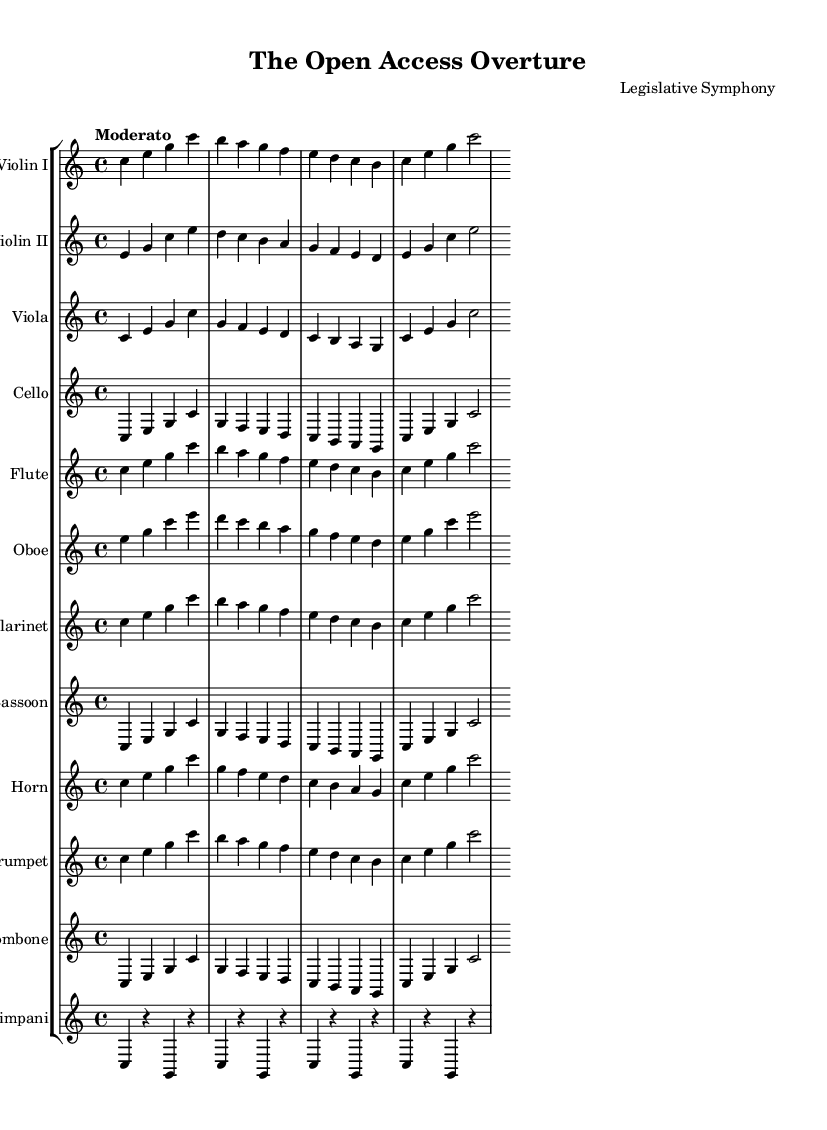What is the key signature of this music? The key signature shows one flat which indicates it is in C major, which has no sharps or flats.
Answer: C major What is the time signature of this music? The time signature is indicated as 4/4, meaning there are four beats in a measure, and the quarter note gets one beat.
Answer: 4/4 What is the tempo marking for this symphony? The tempo marking is "Moderato," indicating a moderate speed of the music.
Answer: Moderato Which instrument has the first melody in the score? The first melody in the score is introduced by the Violin I, which leads the harmonic progression.
Answer: Violin I How many instruments are there in this orchestral suite? The score features a total of twelve different instruments, each represented by its own staff.
Answer: Twelve What is the role of the timpani in this symphony? The timpani part consists of sustained notes, creating rhythmic punctuation and supporting the harmonic structure throughout the music.
Answer: Rhythmic punctuation Which section of the orchestra does the viola belong to? The viola is classified as a string instrument, part of the string section within the orchestra.
Answer: String section 